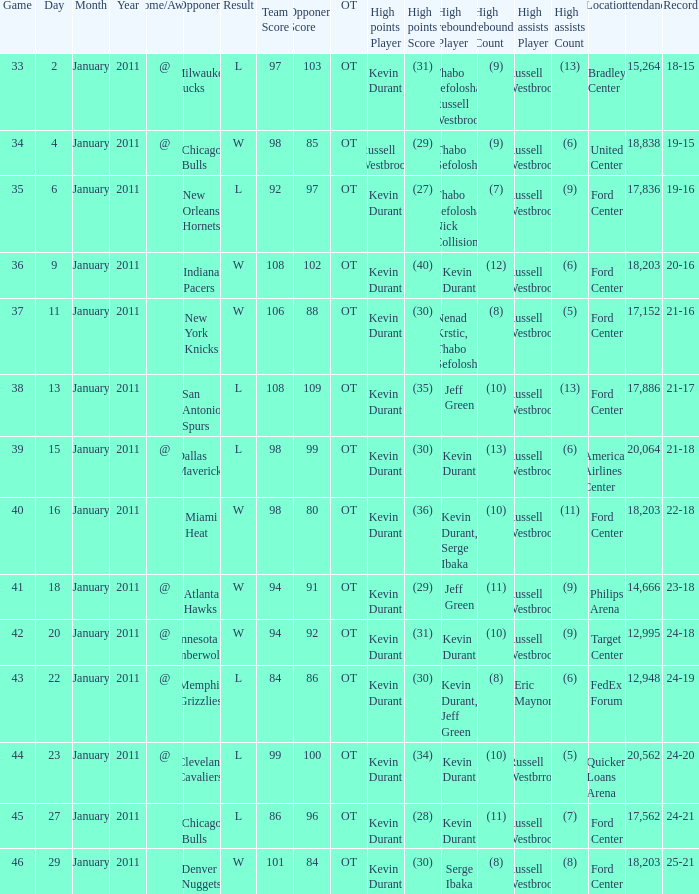Name the location attendance for january 18 Philips Arena 14,666. 